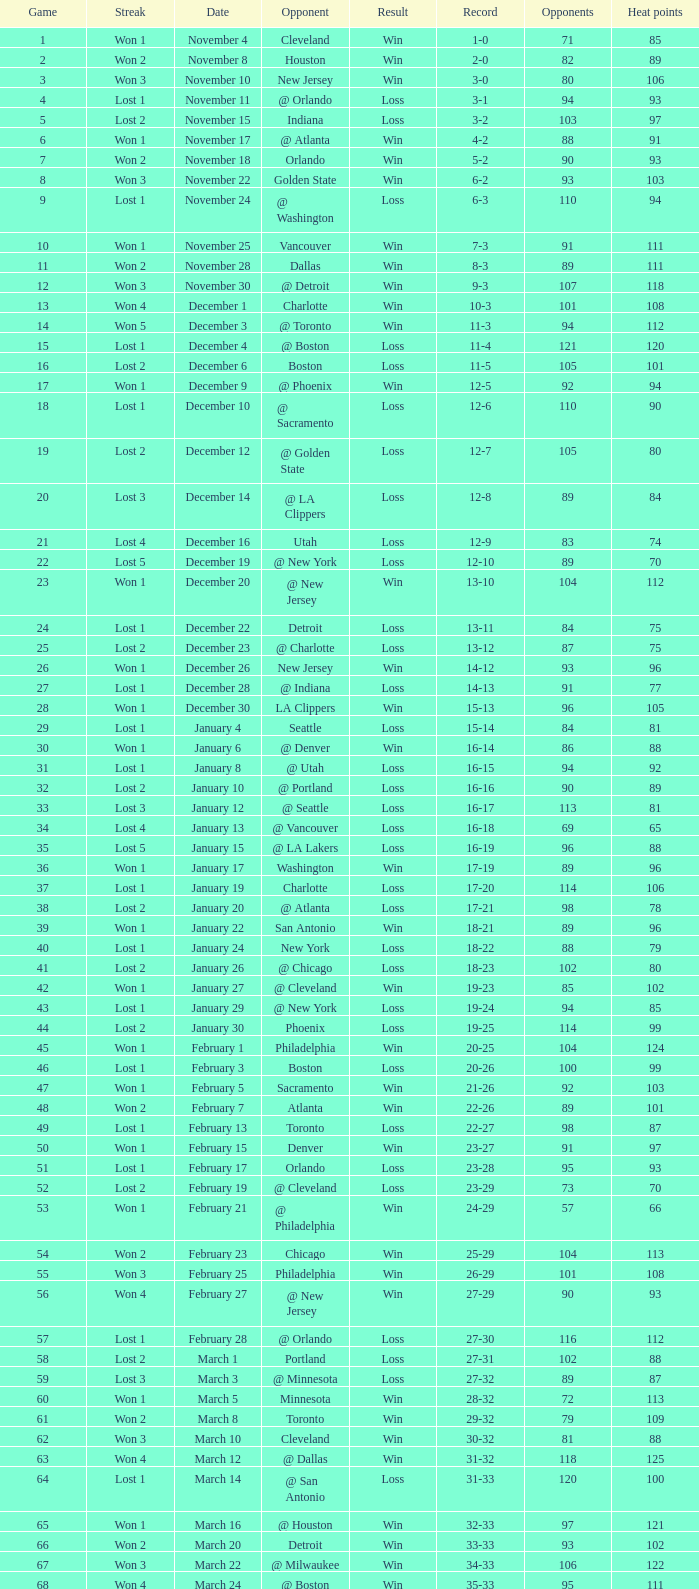What is the highest Game, when Opponents is less than 80, and when Record is "1-0"? 1.0. 